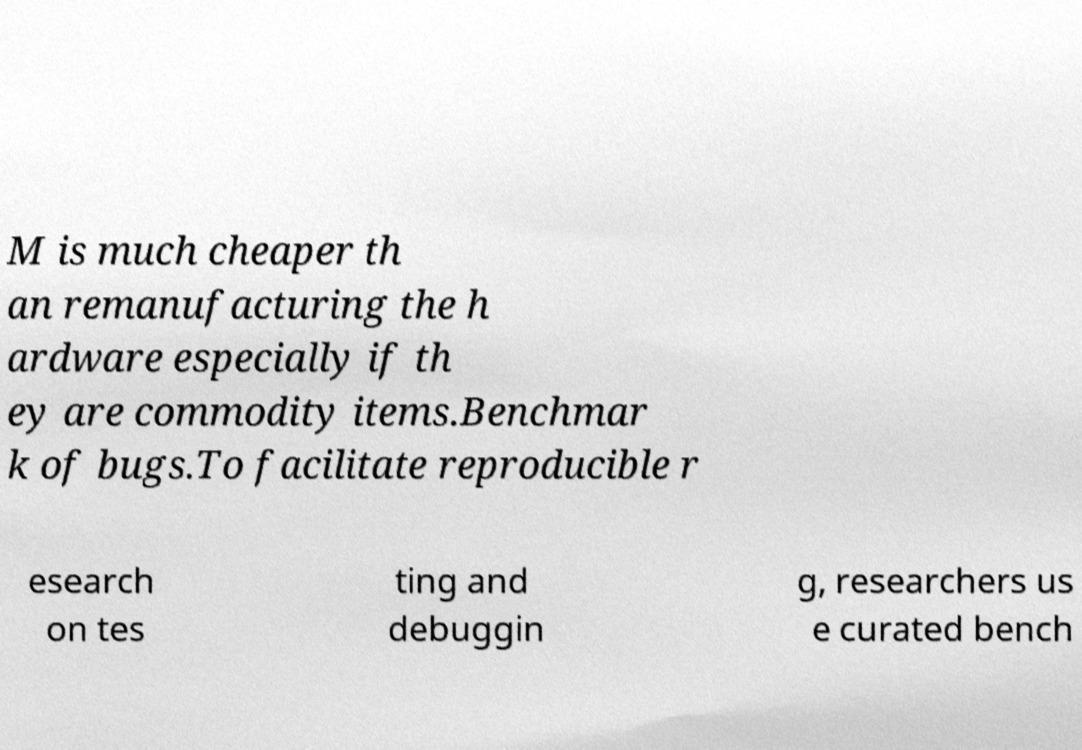There's text embedded in this image that I need extracted. Can you transcribe it verbatim? M is much cheaper th an remanufacturing the h ardware especially if th ey are commodity items.Benchmar k of bugs.To facilitate reproducible r esearch on tes ting and debuggin g, researchers us e curated bench 